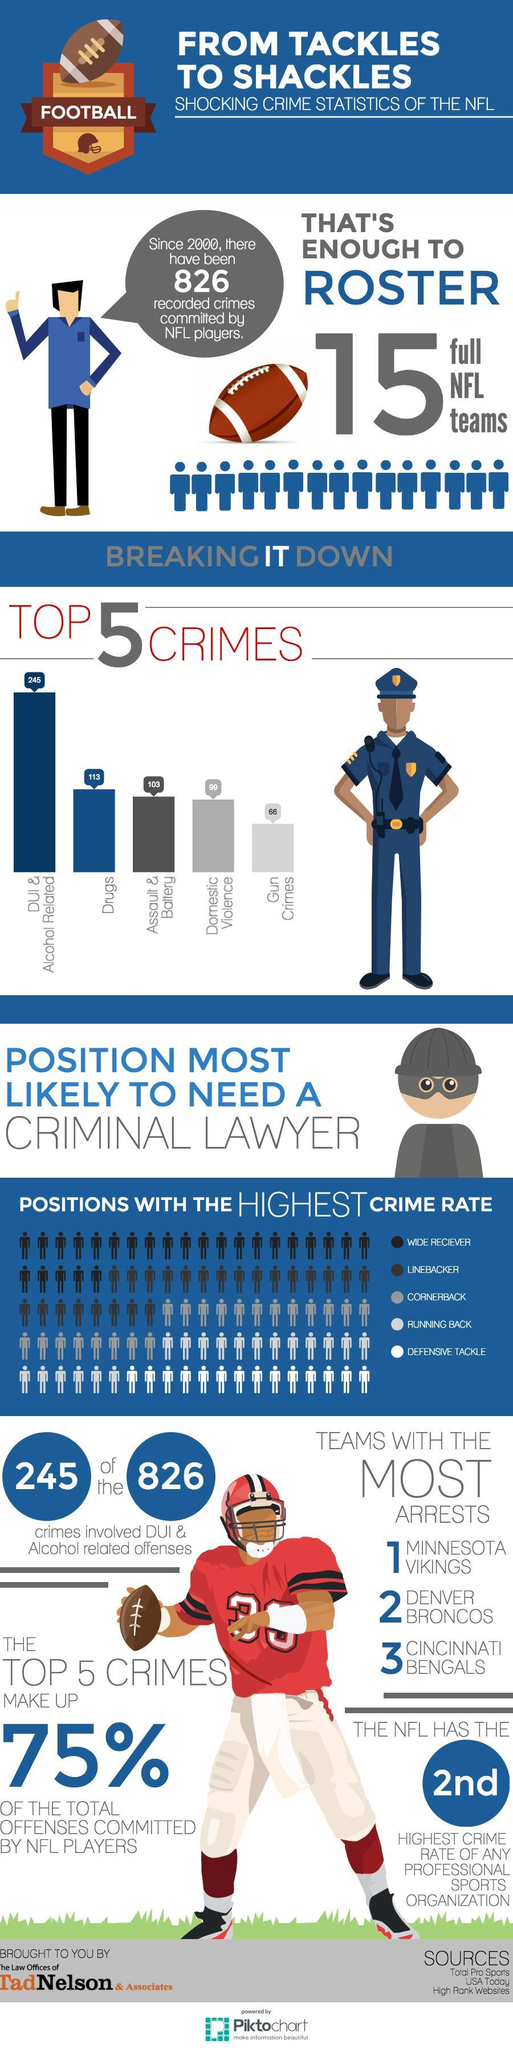What was the number of crimes registered due to domestic violence, 113,103, or 99?
Answer the question with a short phrase. 99 Which player positions recorded the lowest crime rate? DEFENSIVE TACKLE Which player positions recorded had the highest crime rate? Wide Receiver 